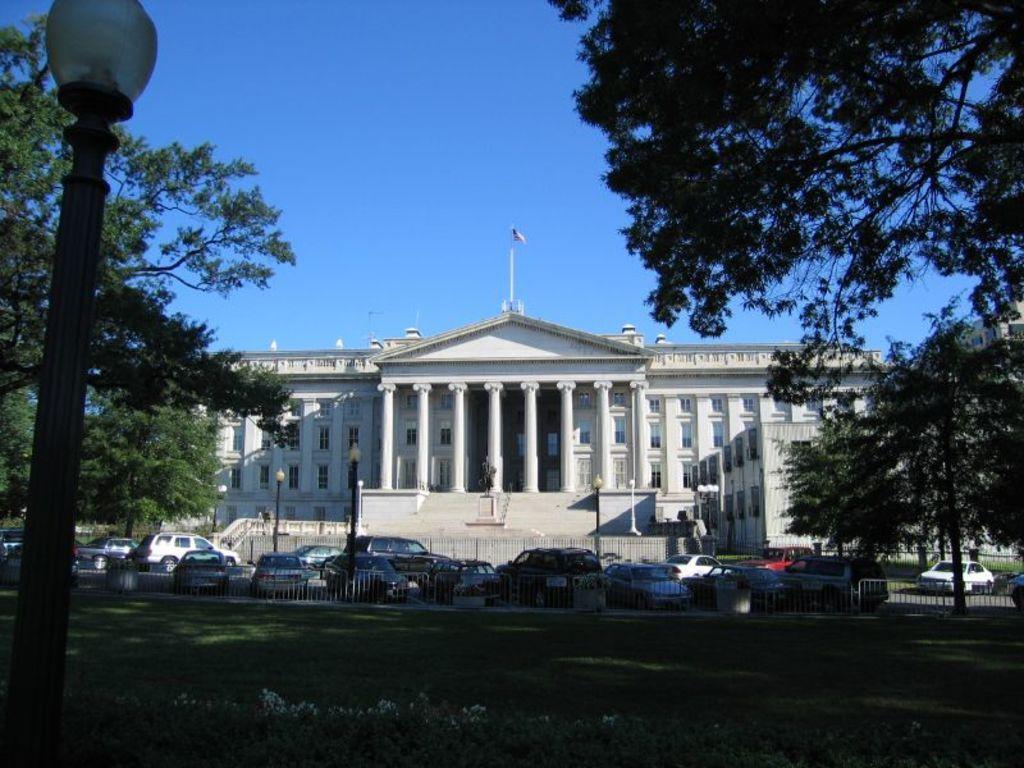In one or two sentences, can you explain what this image depicts? In this image we can see group of vehicles parked on the ground. In the center of the image we can see group of light poles, a building with windows, pillars and a flag on a pole. In the foreground of the image we can see a fence and some plants. On the left and right side of the image we can see some trees. At the top of the image we can see the sky. 